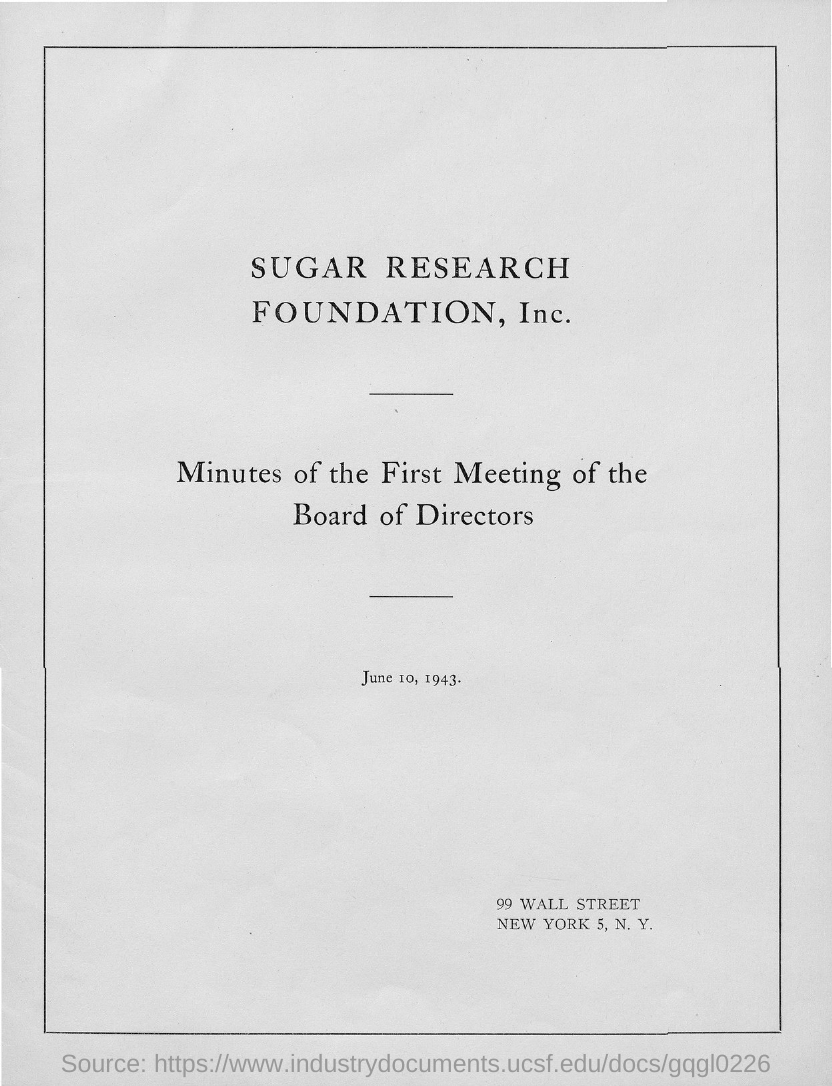Mention a couple of crucial points in this snapshot. The minutes of the meeting are from the first meeting of the board of directors. The second title in this document is 'Minutes of the First Meeting of the Board of Directors.' The Sugar Research Foundation, Inc. was named at the top. 